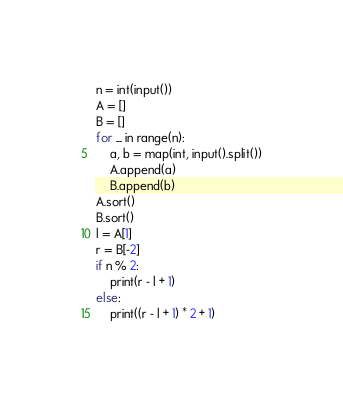<code> <loc_0><loc_0><loc_500><loc_500><_Python_>n = int(input())
A = []
B = []
for _ in range(n):
    a, b = map(int, input().split())
    A.append(a)
    B.append(b)
A.sort()
B.sort()
l = A[1]
r = B[-2]
if n % 2:
    print(r - l + 1)
else:
    print((r - l + 1) * 2 + 1)
</code> 